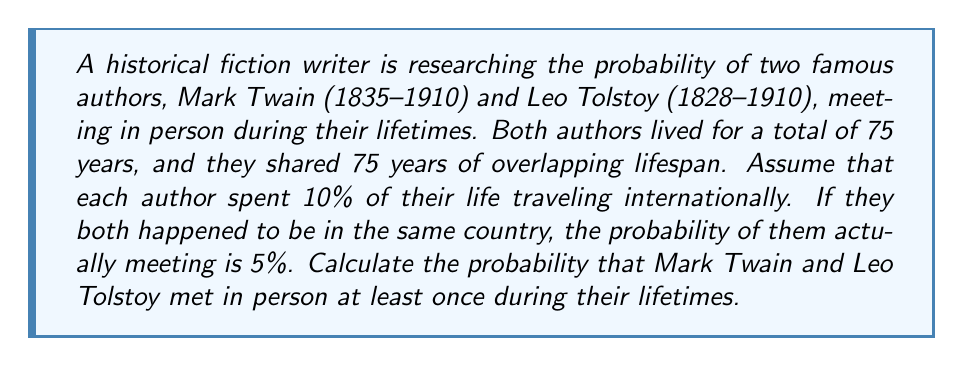Show me your answer to this math problem. Let's approach this step-by-step:

1) First, we need to calculate the probability of both authors being in the same country at the same time:
   - Each author spends 10% of their time traveling internationally
   - Probability of both traveling at the same time: $0.1 \times 0.1 = 0.01$ or 1%

2) Now, we need to consider the overlapping years:
   - They shared 75 years of overlapping lifespan
   - Probability of being in the same country in any given year: $0.01$
   - Probability of not being in the same country in a given year: $1 - 0.01 = 0.99$

3) Probability of not being in the same country for all 75 years:
   $$(0.99)^{75} \approx 0.4723$$

4) Therefore, the probability of being in the same country at least once:
   $$1 - (0.99)^{75} \approx 0.5277$$

5) However, being in the same country doesn't guarantee meeting. The probability of meeting if in the same country is given as 5% or 0.05.

6) So, the final probability of meeting at least once is:
   $$0.5277 \times 0.05 \approx 0.026385$$

Thus, the probability of Mark Twain and Leo Tolstoy meeting at least once during their lifetimes is approximately 0.026385 or about 2.64%.
Answer: $\approx 0.026385$ or $2.64\%$ 